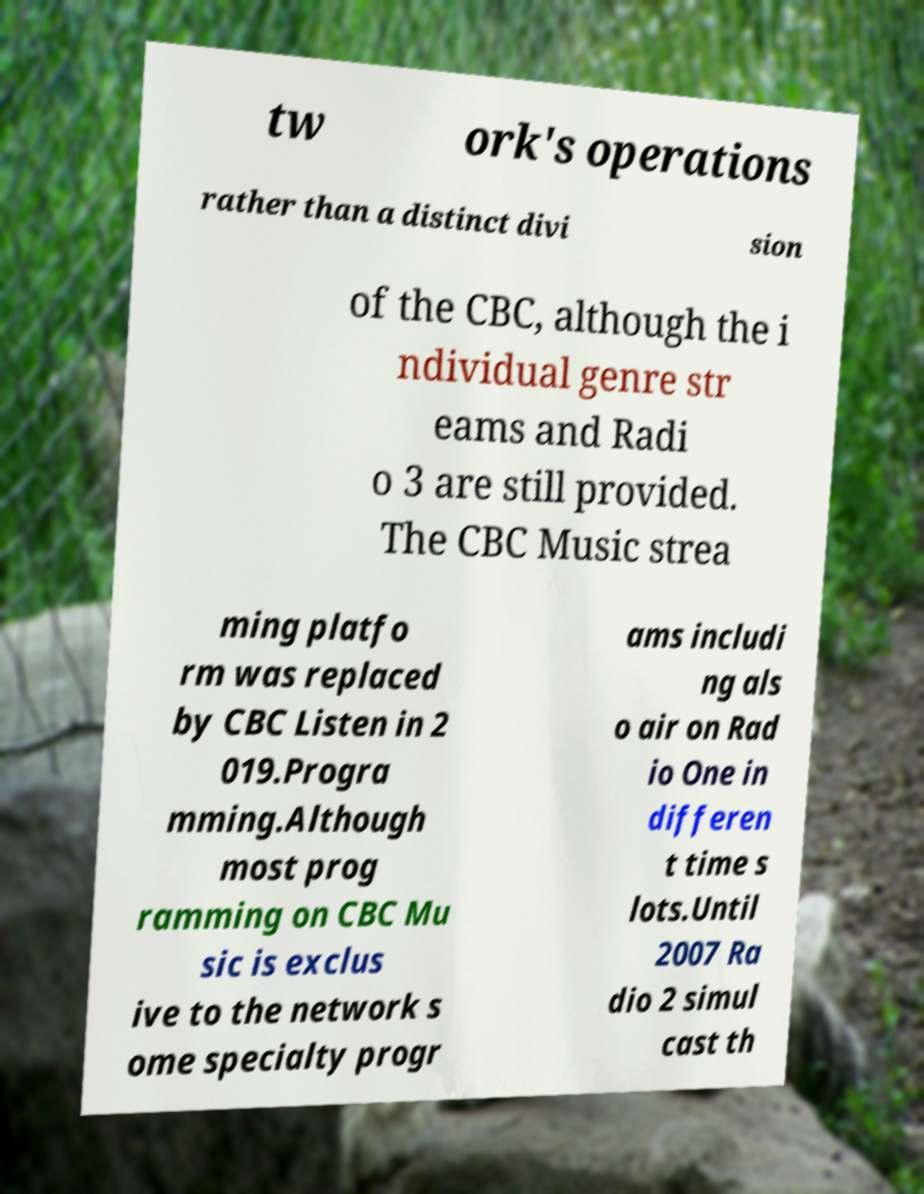Can you read and provide the text displayed in the image?This photo seems to have some interesting text. Can you extract and type it out for me? tw ork's operations rather than a distinct divi sion of the CBC, although the i ndividual genre str eams and Radi o 3 are still provided. The CBC Music strea ming platfo rm was replaced by CBC Listen in 2 019.Progra mming.Although most prog ramming on CBC Mu sic is exclus ive to the network s ome specialty progr ams includi ng als o air on Rad io One in differen t time s lots.Until 2007 Ra dio 2 simul cast th 